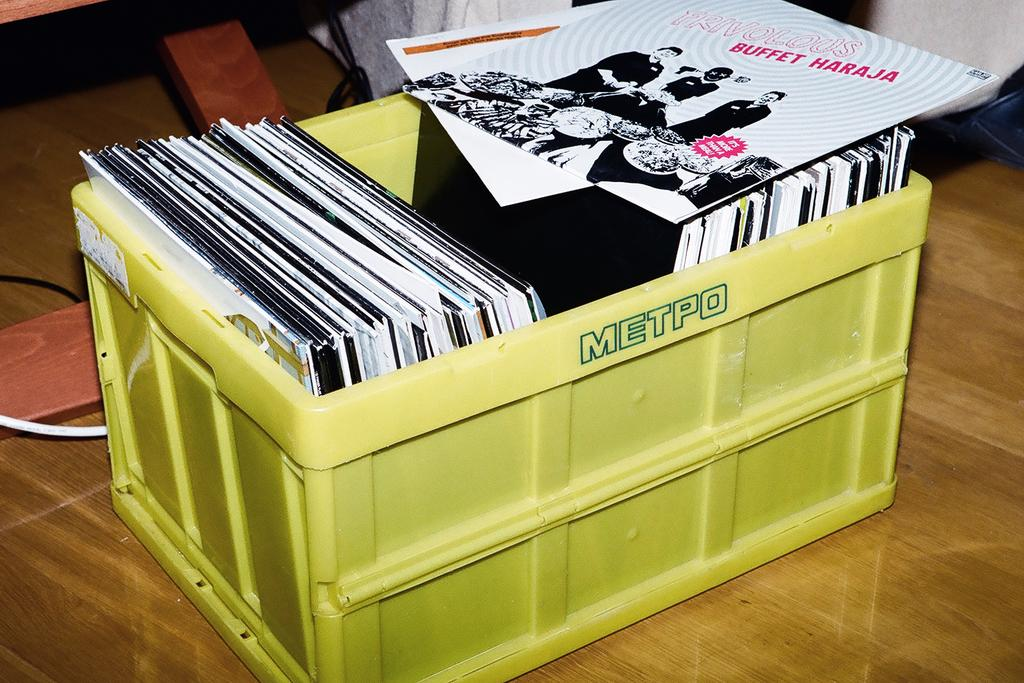<image>
Give a short and clear explanation of the subsequent image. A yellow bin has the word "METPO" on the side. 